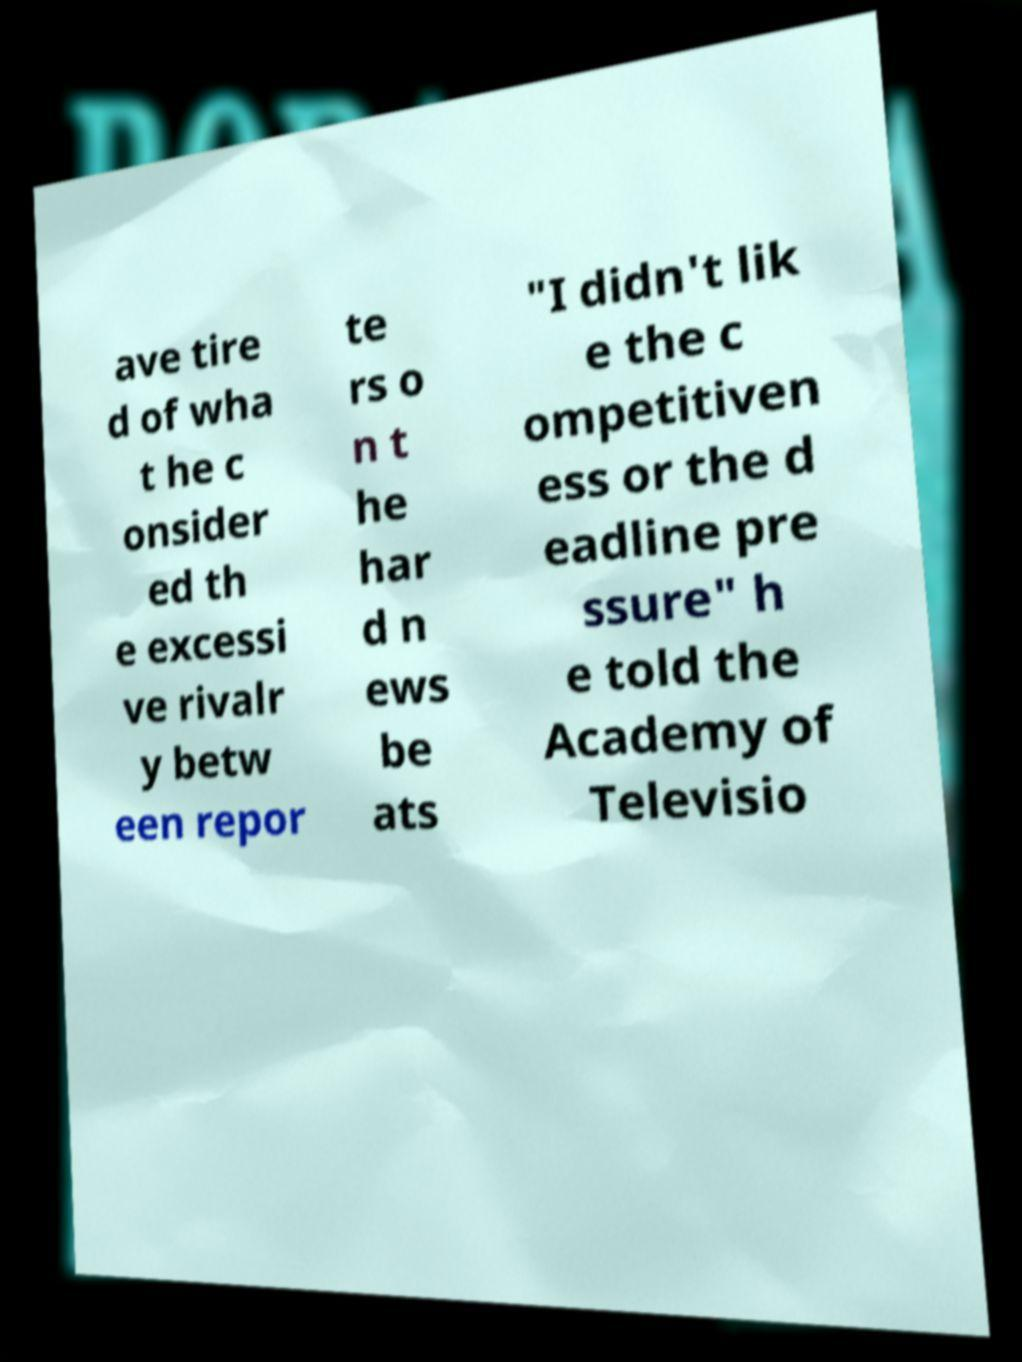For documentation purposes, I need the text within this image transcribed. Could you provide that? ave tire d of wha t he c onsider ed th e excessi ve rivalr y betw een repor te rs o n t he har d n ews be ats "I didn't lik e the c ompetitiven ess or the d eadline pre ssure" h e told the Academy of Televisio 